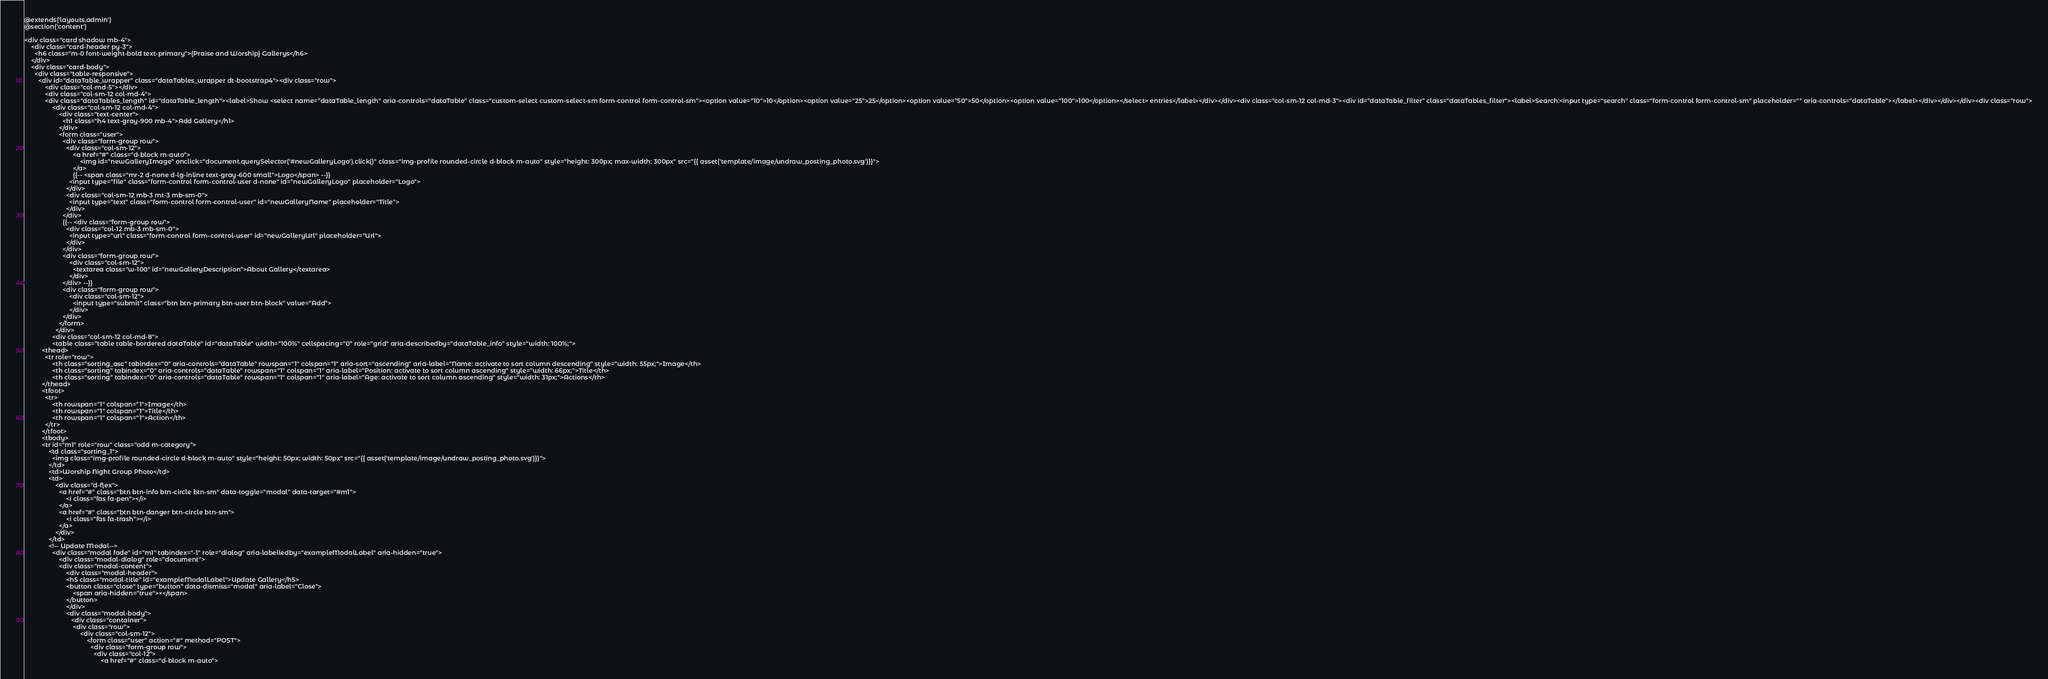Convert code to text. <code><loc_0><loc_0><loc_500><loc_500><_PHP_>@extends('layouts.admin')
@section('content')

<div class="card shadow mb-4">
    <div class="card-header py-3">
      <h6 class="m-0 font-weight-bold text-primary">{Praise and Worship} Gallerys</h6>
    </div>
    <div class="card-body">
      <div class="table-responsive">
        <div id="dataTable_wrapper" class="dataTables_wrapper dt-bootstrap4"><div class="row">
            <div class="col-md-5"></div>
            <div class="col-sm-12 col-md-4">
            <div class="dataTables_length" id="dataTable_length"><label>Show <select name="dataTable_length" aria-controls="dataTable" class="custom-select custom-select-sm form-control form-control-sm"><option value="10">10</option><option value="25">25</option><option value="50">50</option><option value="100">100</option></select> entries</label></div></div><div class="col-sm-12 col-md-3"><div id="dataTable_filter" class="dataTables_filter"><label>Search:<input type="search" class="form-control form-control-sm" placeholder="" aria-controls="dataTable"></label></div></div></div><div class="row">
                <div class="col-sm-12 col-md-4">
                    <div class="text-center">
                      <h1 class="h4 text-gray-900 mb-4">Add Gallery</h1>
                    </div>
                    <form class="user">
                      <div class="form-group row">
                        <div class="col-sm-12">
                            <a href="#" class="d-block m-auto">
                                <img id="newGalleryImage" onclick="document.querySelector('#newGalleryLogo').click()" class="img-profile rounded-circle d-block m-auto" style="height: 300px; max-width: 300px" src="{{ asset('template/image/undraw_posting_photo.svg')}}">
                            </a>
                            {{-- <span class="mr-2 d-none d-lg-inline text-gray-600 small">Logo</span> --}}
                          <input type="file" class="form-control form-control-user d-none" id="newGalleryLogo" placeholder="Logo">
                        </div>
                        <div class="col-sm-12 mb-3 mt-3 mb-sm-0">
                          <input type="text" class="form-control form-control-user" id="newGalleryName" placeholder="Title">
                        </div>
                      </div>
                      {{-- <div class="form-group row">
                        <div class="col-12 mb-3 mb-sm-0">
                          <input type="url" class="form-control form-control-user" id="newGalleryUrl" placeholder="Url">
                        </div>
                      </div>
                      <div class="form-group row">
                          <div class="col-sm-12">
                            <textarea class="w-100" id="newGalleryDescription">About Gallery</textarea>
                          </div>
                      </div> --}}
                      <div class="form-group row">
                          <div class="col-sm-12">
                            <input type="submit" class="btn btn-primary btn-user btn-block" value="Add">
                          </div>
                      </div>
                    </form>
                  </div>
                <div class="col-sm-12 col-md-8">
                <table class="table table-bordered dataTable" id="dataTable" width="100%" cellspacing="0" role="grid" aria-describedby="dataTable_info" style="width: 100%;">
          <thead>
            <tr role="row">
                <th class="sorting_asc" tabindex="0" aria-controls="dataTable" rowspan="1" colspan="1" aria-sort="ascending" aria-label="Name: activate to sort column descending" style="width: 55px;">Image</th>
                <th class="sorting" tabindex="0" aria-controls="dataTable" rowspan="1" colspan="1" aria-label="Position: activate to sort column ascending" style="width: 66px;">Title</th>
                <th class="sorting" tabindex="0" aria-controls="dataTable" rowspan="1" colspan="1" aria-label="Age: activate to sort column ascending" style="width: 31px;">Actions</th>
          </thead>
          <tfoot>
            <tr>
                <th rowspan="1" colspan="1">Image</th>
                <th rowspan="1" colspan="1">Title</th>
                <th rowspan="1" colspan="1">Action</th>
            </tr>
          </tfoot>
          <tbody>
          <tr id="m1" role="row" class="odd m-category">
              <td class="sorting_1">
                <img class="img-profile rounded-circle d-block m-auto" style="height: 50px; width: 50px" src="{{ asset('template/image/undraw_posting_photo.svg')}}">
              </td>
              <td>Worship Night Group Photo</td>
              <td>
                  <div class="d-flex">
                    <a href="#" class="btn btn-info btn-circle btn-sm" data-toggle="modal" data-target="#m1">
                        <i class="fas fa-pen"></i>
                    </a>
                    <a href="#" class="btn btn-danger btn-circle btn-sm">
                        <i class="fas fa-trash"></i>
                    </a>
                  </div>
              </td>
              <!-- Update Modal-->
                <div class="modal fade" id="m1" tabindex="-1" role="dialog" aria-labelledby="exampleModalLabel" aria-hidden="true">
                    <div class="modal-dialog" role="document">
                    <div class="modal-content">
                        <div class="modal-header">
                        <h5 class="modal-title" id="exampleModalLabel">Update Gallery</h5>
                        <button class="close" type="button" data-dismiss="modal" aria-label="Close">
                            <span aria-hidden="true">×</span>
                        </button>
                        </div>
                        <div class="modal-body">
                           <div class="container">
                            <div class="row">
                                <div class="col-sm-12">
                                    <form class="user" action="#" method="POST">
                                      <div class="form-group row">
                                        <div class="col-12">
                                            <a href="#" class="d-block m-auto"></code> 